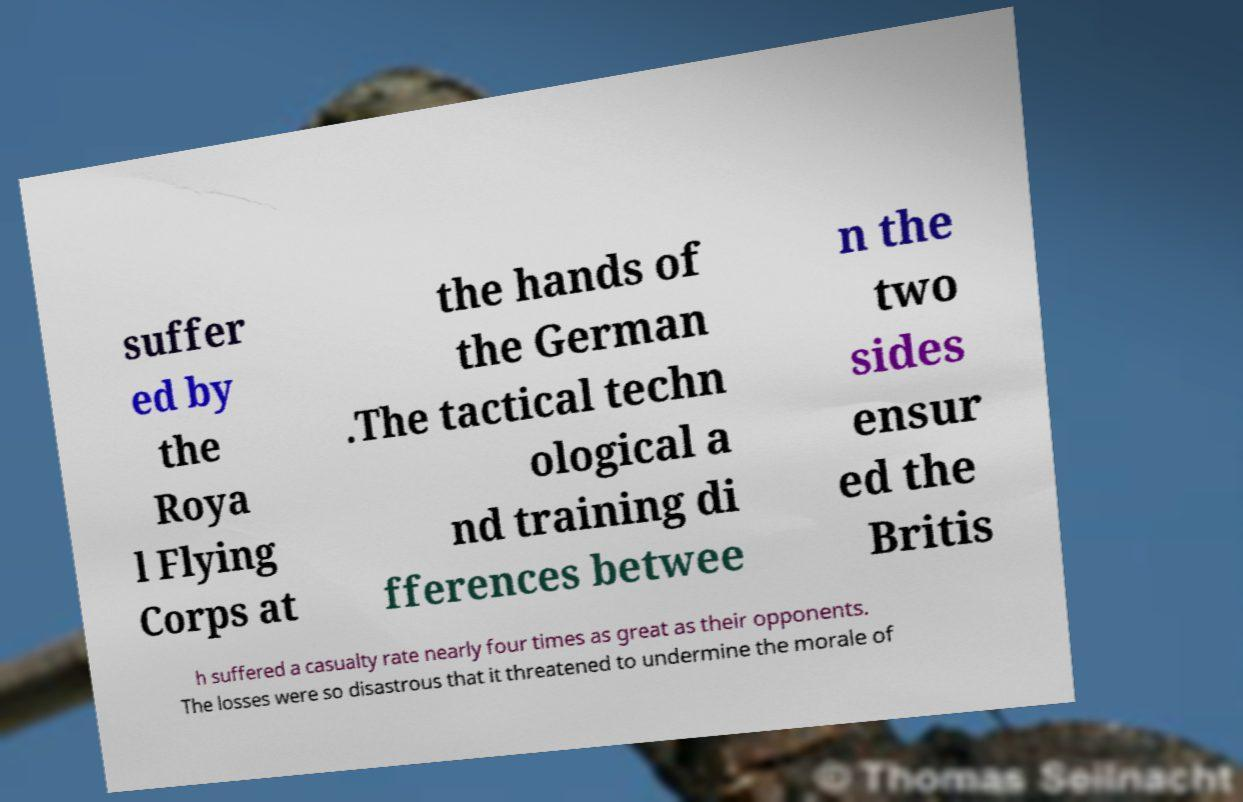Can you read and provide the text displayed in the image?This photo seems to have some interesting text. Can you extract and type it out for me? suffer ed by the Roya l Flying Corps at the hands of the German .The tactical techn ological a nd training di fferences betwee n the two sides ensur ed the Britis h suffered a casualty rate nearly four times as great as their opponents. The losses were so disastrous that it threatened to undermine the morale of 